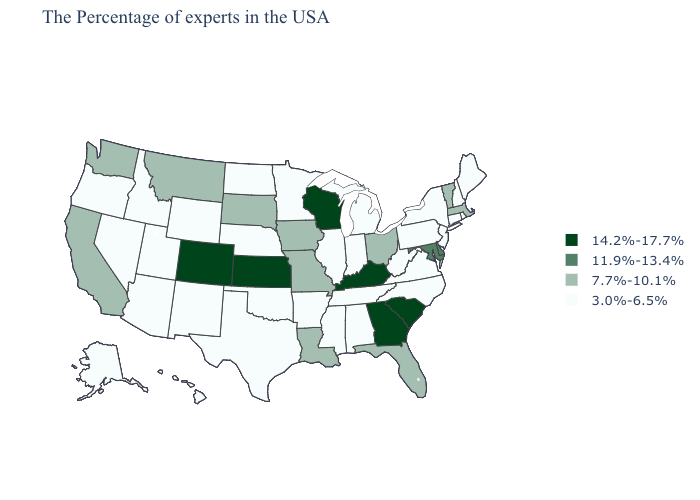Which states have the lowest value in the USA?
Short answer required. Maine, Rhode Island, New Hampshire, Connecticut, New York, New Jersey, Pennsylvania, Virginia, North Carolina, West Virginia, Michigan, Indiana, Alabama, Tennessee, Illinois, Mississippi, Arkansas, Minnesota, Nebraska, Oklahoma, Texas, North Dakota, Wyoming, New Mexico, Utah, Arizona, Idaho, Nevada, Oregon, Alaska, Hawaii. What is the highest value in states that border Ohio?
Be succinct. 14.2%-17.7%. Does Mississippi have the lowest value in the South?
Give a very brief answer. Yes. What is the lowest value in the USA?
Write a very short answer. 3.0%-6.5%. What is the value of Alabama?
Concise answer only. 3.0%-6.5%. What is the lowest value in states that border Oklahoma?
Keep it brief. 3.0%-6.5%. What is the highest value in the West ?
Keep it brief. 14.2%-17.7%. Among the states that border Oregon , which have the highest value?
Quick response, please. California, Washington. Does Maine have a lower value than Oklahoma?
Short answer required. No. Among the states that border Delaware , does Maryland have the lowest value?
Keep it brief. No. Does Arizona have a lower value than Colorado?
Concise answer only. Yes. How many symbols are there in the legend?
Quick response, please. 4. What is the lowest value in states that border New York?
Give a very brief answer. 3.0%-6.5%. Which states hav the highest value in the South?
Answer briefly. South Carolina, Georgia, Kentucky. Name the states that have a value in the range 14.2%-17.7%?
Concise answer only. South Carolina, Georgia, Kentucky, Wisconsin, Kansas, Colorado. 